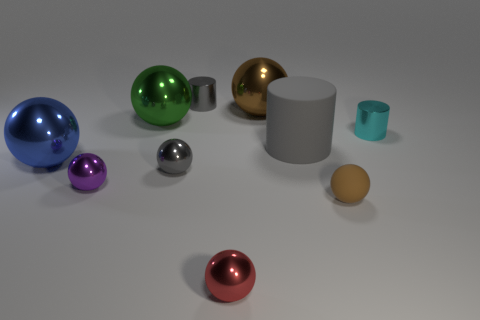There is a gray object on the right side of the gray cylinder to the left of the large brown thing; what is its material?
Your answer should be very brief. Rubber. There is a brown thing that is in front of the blue metallic ball; what is its material?
Your answer should be very brief. Rubber. What number of purple things have the same shape as the red metallic thing?
Your answer should be very brief. 1. The gray cylinder that is in front of the cylinder that is to the left of the brown thing that is behind the green thing is made of what material?
Offer a very short reply. Rubber. Are there any gray cylinders in front of the cyan metallic object?
Ensure brevity in your answer.  Yes. The cyan object that is the same size as the purple sphere is what shape?
Provide a succinct answer. Cylinder. Does the large blue ball have the same material as the small purple object?
Provide a short and direct response. Yes. What number of rubber objects are either red blocks or cyan objects?
Provide a short and direct response. 0. There is a object that is the same color as the matte ball; what is its shape?
Make the answer very short. Sphere. Do the shiny ball that is in front of the purple metal object and the large cylinder have the same color?
Keep it short and to the point. No. 